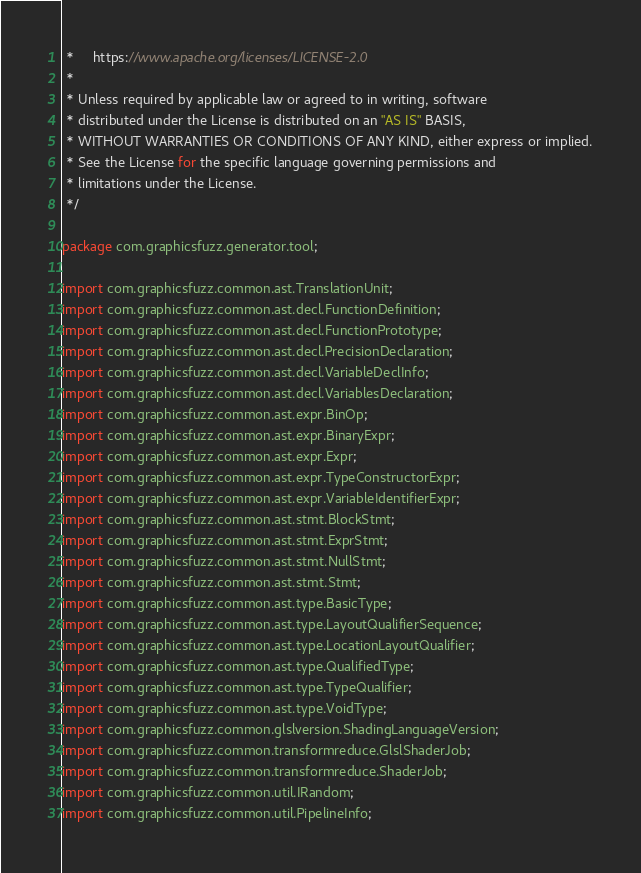<code> <loc_0><loc_0><loc_500><loc_500><_Java_> *     https://www.apache.org/licenses/LICENSE-2.0
 *
 * Unless required by applicable law or agreed to in writing, software
 * distributed under the License is distributed on an "AS IS" BASIS,
 * WITHOUT WARRANTIES OR CONDITIONS OF ANY KIND, either express or implied.
 * See the License for the specific language governing permissions and
 * limitations under the License.
 */

package com.graphicsfuzz.generator.tool;

import com.graphicsfuzz.common.ast.TranslationUnit;
import com.graphicsfuzz.common.ast.decl.FunctionDefinition;
import com.graphicsfuzz.common.ast.decl.FunctionPrototype;
import com.graphicsfuzz.common.ast.decl.PrecisionDeclaration;
import com.graphicsfuzz.common.ast.decl.VariableDeclInfo;
import com.graphicsfuzz.common.ast.decl.VariablesDeclaration;
import com.graphicsfuzz.common.ast.expr.BinOp;
import com.graphicsfuzz.common.ast.expr.BinaryExpr;
import com.graphicsfuzz.common.ast.expr.Expr;
import com.graphicsfuzz.common.ast.expr.TypeConstructorExpr;
import com.graphicsfuzz.common.ast.expr.VariableIdentifierExpr;
import com.graphicsfuzz.common.ast.stmt.BlockStmt;
import com.graphicsfuzz.common.ast.stmt.ExprStmt;
import com.graphicsfuzz.common.ast.stmt.NullStmt;
import com.graphicsfuzz.common.ast.stmt.Stmt;
import com.graphicsfuzz.common.ast.type.BasicType;
import com.graphicsfuzz.common.ast.type.LayoutQualifierSequence;
import com.graphicsfuzz.common.ast.type.LocationLayoutQualifier;
import com.graphicsfuzz.common.ast.type.QualifiedType;
import com.graphicsfuzz.common.ast.type.TypeQualifier;
import com.graphicsfuzz.common.ast.type.VoidType;
import com.graphicsfuzz.common.glslversion.ShadingLanguageVersion;
import com.graphicsfuzz.common.transformreduce.GlslShaderJob;
import com.graphicsfuzz.common.transformreduce.ShaderJob;
import com.graphicsfuzz.common.util.IRandom;
import com.graphicsfuzz.common.util.PipelineInfo;</code> 